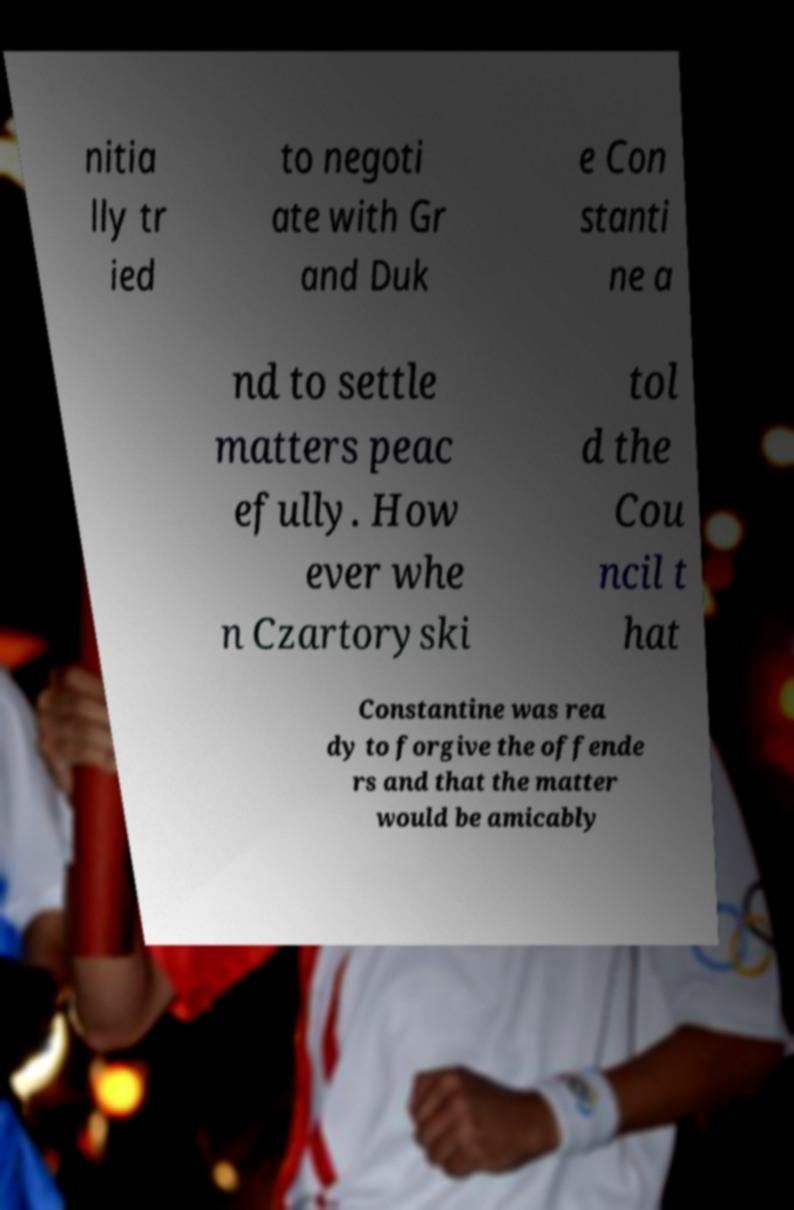Please read and relay the text visible in this image. What does it say? nitia lly tr ied to negoti ate with Gr and Duk e Con stanti ne a nd to settle matters peac efully. How ever whe n Czartoryski tol d the Cou ncil t hat Constantine was rea dy to forgive the offende rs and that the matter would be amicably 